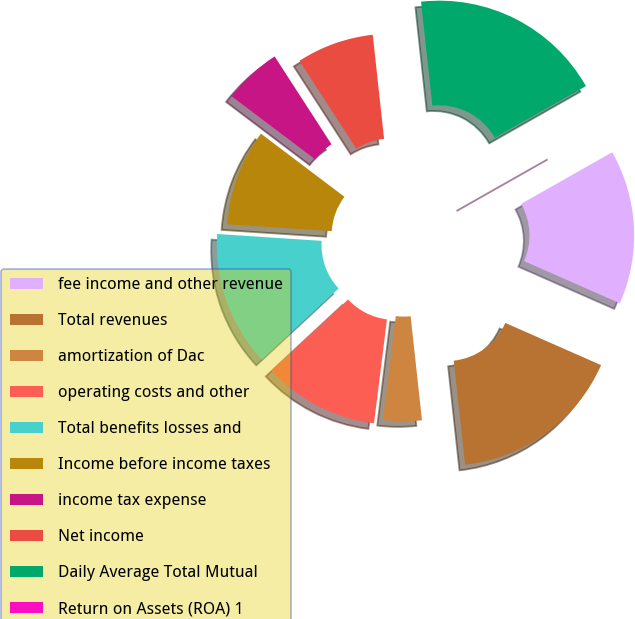Convert chart to OTSL. <chart><loc_0><loc_0><loc_500><loc_500><pie_chart><fcel>fee income and other revenue<fcel>Total revenues<fcel>amortization of Dac<fcel>operating costs and other<fcel>Total benefits losses and<fcel>Income before income taxes<fcel>income tax expense<fcel>Net income<fcel>Daily Average Total Mutual<fcel>Return on Assets (ROA) 1<nl><fcel>14.81%<fcel>16.67%<fcel>3.7%<fcel>11.11%<fcel>12.96%<fcel>9.26%<fcel>5.56%<fcel>7.41%<fcel>18.52%<fcel>0.0%<nl></chart> 